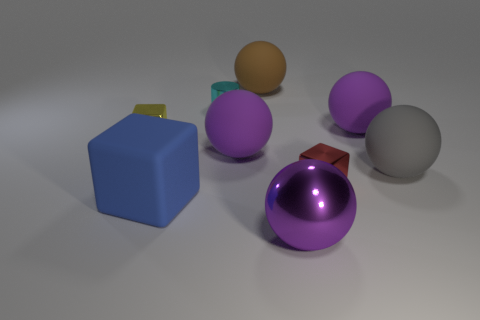What materials do the objects in the image appear to be made of? The objects in the image appear to be made of various materials. The purple, silver, and yellow spheres, as well as the tiny cyan object, look metallic, reflecting light with a high sheen. The blue block appears to have a matte, possibly plastic or rubber-like, surface. 